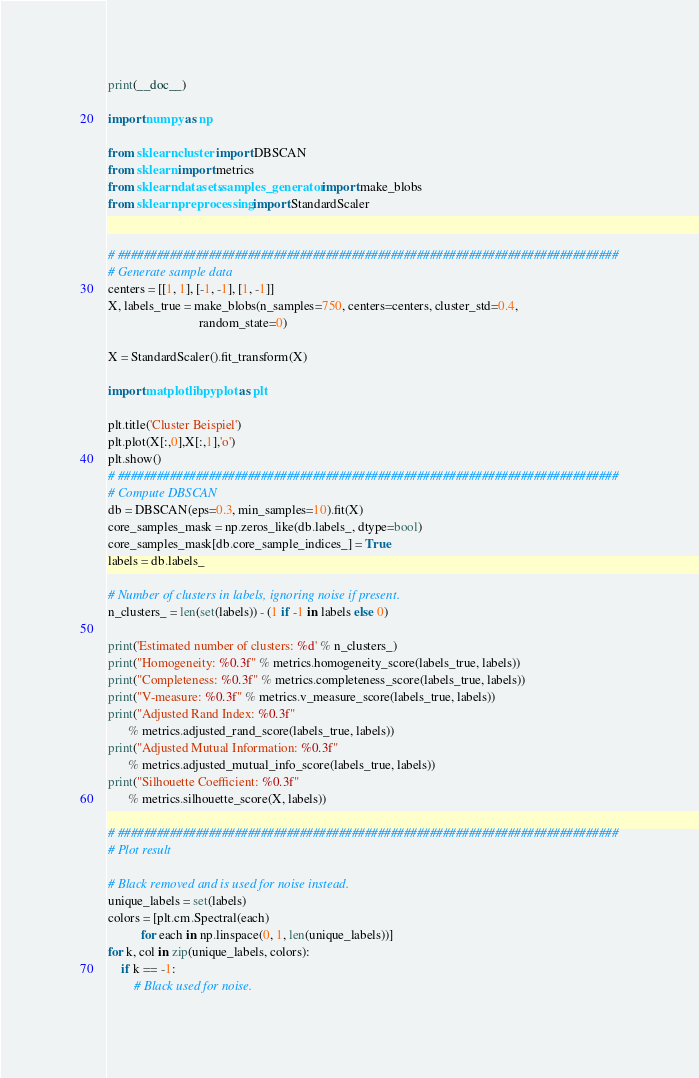Convert code to text. <code><loc_0><loc_0><loc_500><loc_500><_Python_>print(__doc__)

import numpy as np

from sklearn.cluster import DBSCAN
from sklearn import metrics
from sklearn.datasets.samples_generator import make_blobs
from sklearn.preprocessing import StandardScaler


# #############################################################################
# Generate sample data
centers = [[1, 1], [-1, -1], [1, -1]]
X, labels_true = make_blobs(n_samples=750, centers=centers, cluster_std=0.4,
                            random_state=0)

X = StandardScaler().fit_transform(X)

import matplotlib.pyplot as plt

plt.title('Cluster Beispiel')
plt.plot(X[:,0],X[:,1],'o')
plt.show()
# #############################################################################
# Compute DBSCAN
db = DBSCAN(eps=0.3, min_samples=10).fit(X)
core_samples_mask = np.zeros_like(db.labels_, dtype=bool)
core_samples_mask[db.core_sample_indices_] = True
labels = db.labels_

# Number of clusters in labels, ignoring noise if present.
n_clusters_ = len(set(labels)) - (1 if -1 in labels else 0)

print('Estimated number of clusters: %d' % n_clusters_)
print("Homogeneity: %0.3f" % metrics.homogeneity_score(labels_true, labels))
print("Completeness: %0.3f" % metrics.completeness_score(labels_true, labels))
print("V-measure: %0.3f" % metrics.v_measure_score(labels_true, labels))
print("Adjusted Rand Index: %0.3f"
      % metrics.adjusted_rand_score(labels_true, labels))
print("Adjusted Mutual Information: %0.3f"
      % metrics.adjusted_mutual_info_score(labels_true, labels))
print("Silhouette Coefficient: %0.3f"
      % metrics.silhouette_score(X, labels))

# #############################################################################
# Plot result

# Black removed and is used for noise instead.
unique_labels = set(labels)
colors = [plt.cm.Spectral(each)
          for each in np.linspace(0, 1, len(unique_labels))]
for k, col in zip(unique_labels, colors):
    if k == -1:
        # Black used for noise.</code> 